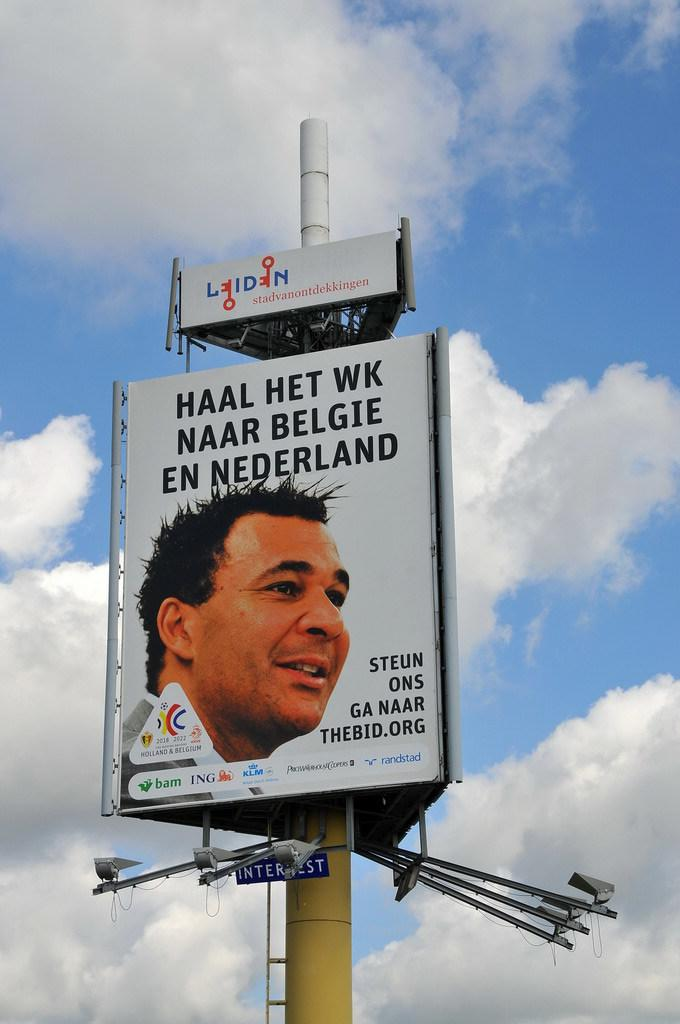<image>
Relay a brief, clear account of the picture shown. A billboard in a foreign language of a man with dark hair. 